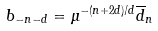Convert formula to latex. <formula><loc_0><loc_0><loc_500><loc_500>b _ { - n - d } = \mu ^ { - ( n + 2 d ) / d } { \overline { d } } _ { n }</formula> 